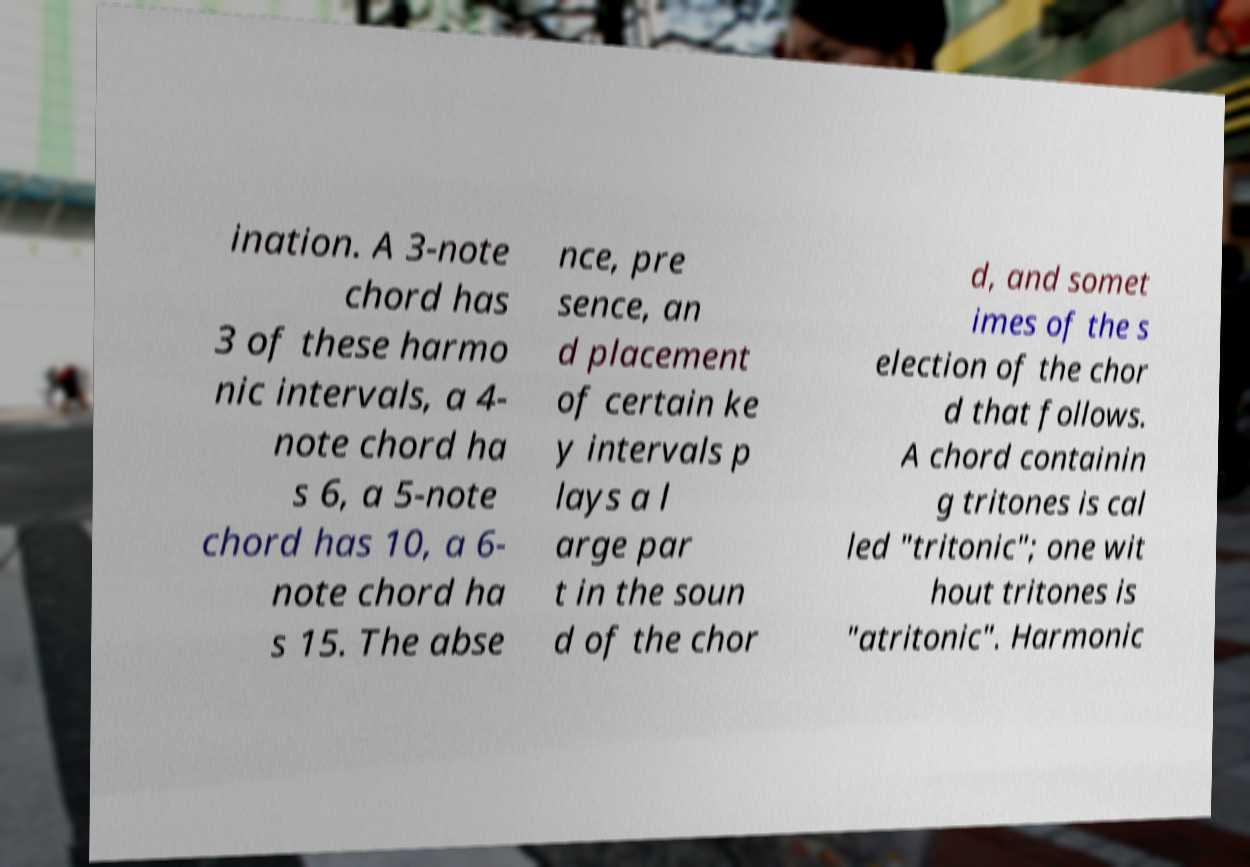Please identify and transcribe the text found in this image. ination. A 3-note chord has 3 of these harmo nic intervals, a 4- note chord ha s 6, a 5-note chord has 10, a 6- note chord ha s 15. The abse nce, pre sence, an d placement of certain ke y intervals p lays a l arge par t in the soun d of the chor d, and somet imes of the s election of the chor d that follows. A chord containin g tritones is cal led "tritonic"; one wit hout tritones is "atritonic". Harmonic 